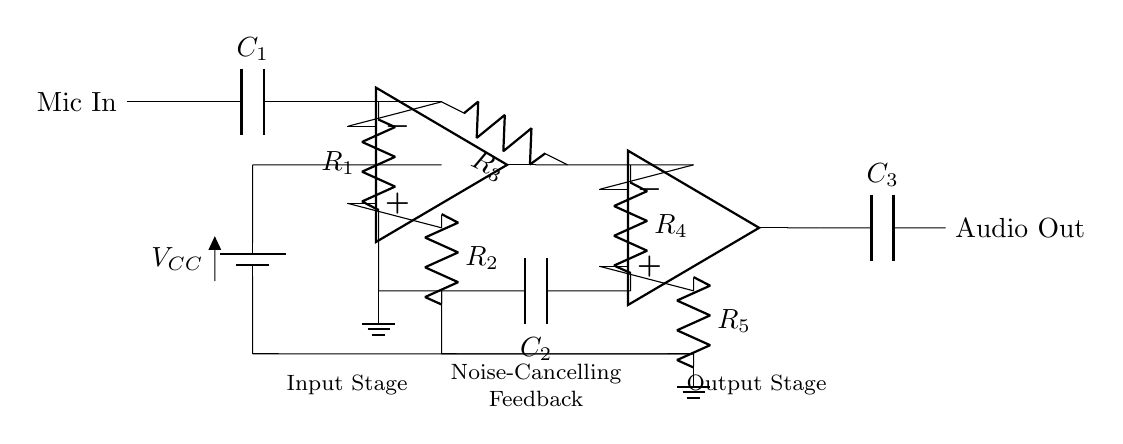What is the first component the mic signal passes through? The microphone signal first passes through a capacitor labeled C1, which blocks DC voltage and allows the AC audio signal to pass through.
Answer: C1 How many resistors are present in the circuit? By counting the resistors labeled R1, R2, R3, R4, and R5, we can determine there are five resistors in total.
Answer: 5 What type of circuit is this? This circuit is an audio preamplifier designed for noise cancellation, as indicated by the use of op-amps and feedback components.
Answer: Audio preamplifier What is the purpose of the feedback loop in this circuit? The feedback loop, which includes resistors R4 and C2, helps to reduce noise and improve audio clarity by stabilizing the gain and mitigating unwanted signals.
Answer: Noise reduction What is the function of the operational amplifiers in the circuit? The operational amplifiers (op-amp) amplify the audio signal, providing higher output levels suitable for further processing or transmission, thus enhancing overall audio quality.
Answer: Amplification Which component provides the power supply for the circuit? The power supply is provided by a battery labeled VCC which connects to both op-amps, powering the circuit for operation.
Answer: VCC What is the output of this circuit? The output of the circuit is the audio signal, which is filtered through capacitor C3 before being sent out, ensuring that only the desired audio frequencies are delivered.
Answer: Audio Out 